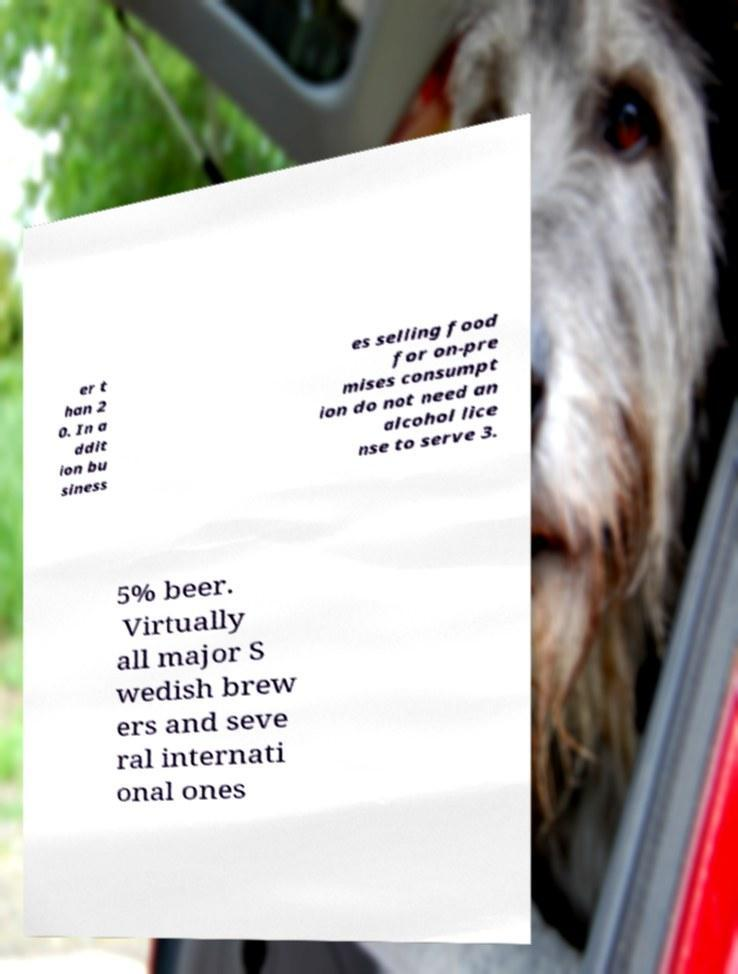I need the written content from this picture converted into text. Can you do that? er t han 2 0. In a ddit ion bu siness es selling food for on-pre mises consumpt ion do not need an alcohol lice nse to serve 3. 5% beer. Virtually all major S wedish brew ers and seve ral internati onal ones 